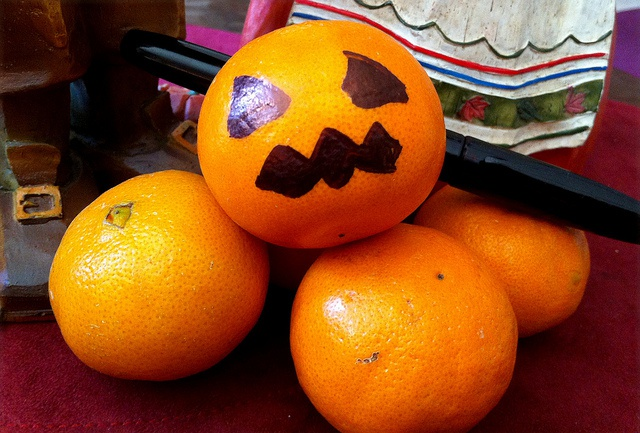Describe the objects in this image and their specific colors. I can see orange in black, orange, brown, and red tones, orange in black, red, orange, brown, and maroon tones, orange in black, orange, red, maroon, and gold tones, and orange in black, red, brown, and maroon tones in this image. 